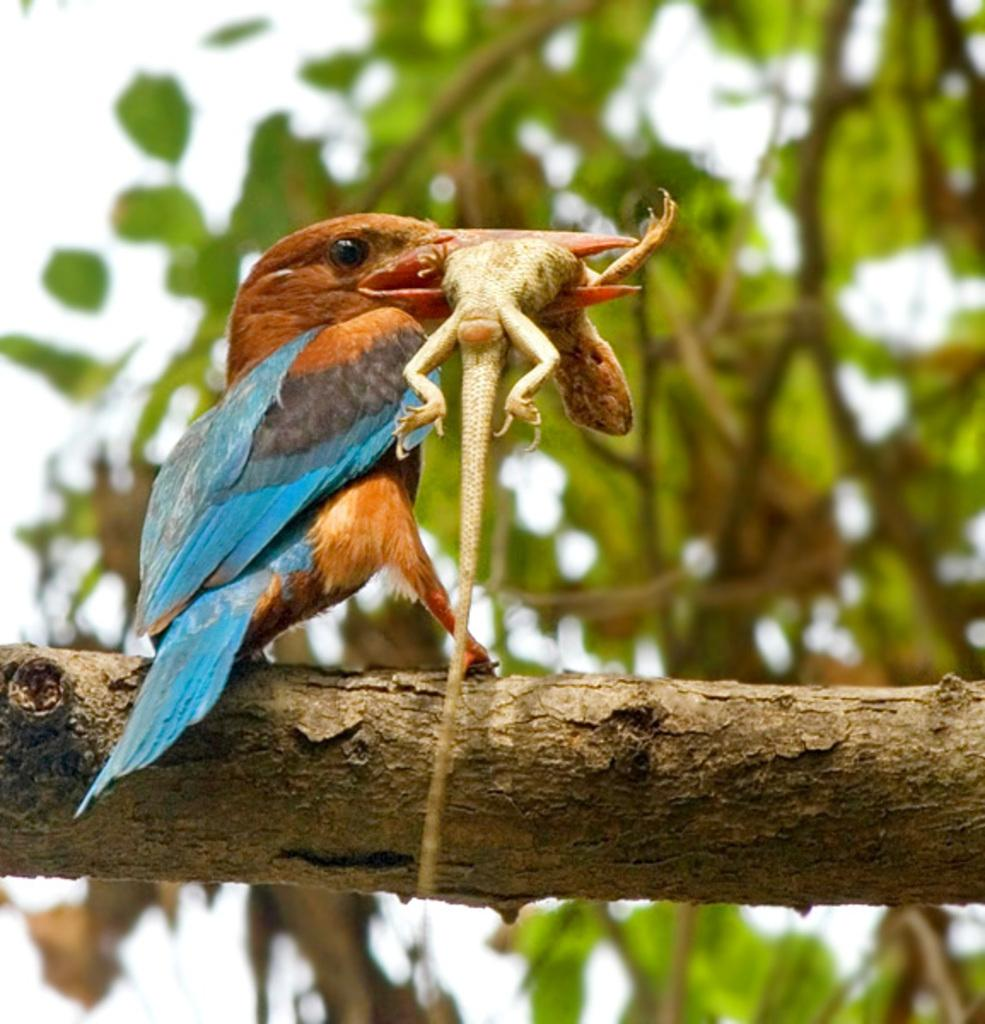What animal can be seen in the image? There is a bird in the image. What is the bird doing in the image? The bird is holding a lizard in its mouth. What can be seen in the background of the image? There are branches, leaves, and the sky visible in the background of the image. Who is the coach of the bird's baseball team in the image? There is no baseball team or coach present in the image; it features a bird holding a lizard. How many friends does the bird have in the image? There is no information about friends in the image; it only shows a bird holding a lizard. 